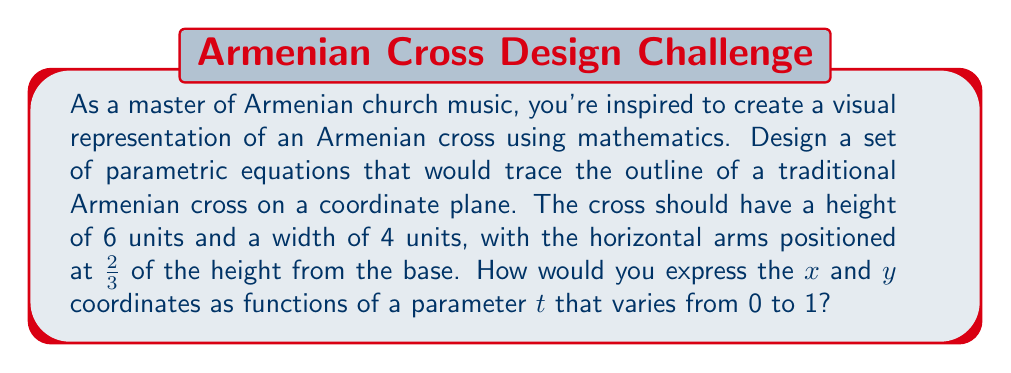Solve this math problem. To create parametric equations for an Armenian cross, we need to break down the shape into segments and define equations for each. Let's approach this step-by-step:

1) First, let's define the dimensions:
   - Height: 6 units
   - Width: 4 units
   - Horizontal arms at y = 4 (2/3 of the height from the base)

2) We'll use piecewise functions for x(t) and y(t), where t varies from 0 to 1.

3) Let's break down the cross into 8 segments, each corresponding to a range of t:
   - 0 ≤ t < 1/8: Bottom to left arm
   - 1/8 ≤ t < 2/8: Left arm
   - 2/8 ≤ t < 3/8: Left arm to top
   - 3/8 ≤ t < 4/8: Top
   - 4/8 ≤ t < 5/8: Top to right arm
   - 5/8 ≤ t < 6/8: Right arm
   - 6/8 ≤ t < 7/8: Right arm to bottom
   - 7/8 ≤ t ≤ 1: Bottom

4) Now, let's define the equations for each segment:

   For x(t):
   $$x(t) = \begin{cases}
   -1 & 0 \leq t < \frac{1}{8} \\
   -2 + 8t & \frac{1}{8} \leq t < \frac{2}{8} \\
   -1 & \frac{2}{8} \leq t < \frac{3}{8} \\
   -2 + 8t & \frac{3}{8} \leq t < \frac{4}{8} \\
   1 & \frac{4}{8} \leq t < \frac{5}{8} \\
   -2 + 8t & \frac{5}{8} \leq t < \frac{6}{8} \\
   1 & \frac{6}{8} \leq t < \frac{7}{8} \\
   6 - 8t & \frac{7}{8} \leq t \leq 1
   \end{cases}$$

   For y(t):
   $$y(t) = \begin{cases}
   8t & 0 \leq t < \frac{1}{8} \\
   1 & \frac{1}{8} \leq t < \frac{2}{8} \\
   -4 + 24t & \frac{2}{8} \leq t < \frac{3}{8} \\
   3 & \frac{3}{8} \leq t < \frac{4}{8} \\
   12 - 24t & \frac{4}{8} \leq t < \frac{5}{8} \\
   1 & \frac{5}{8} \leq t < \frac{6}{8} \\
   8 - 8t & \frac{6}{8} \leq t < \frac{7}{8} \\
   0 & \frac{7}{8} \leq t \leq 1
   \end{cases}$$

5) These equations will trace the outline of an Armenian cross when t varies from 0 to 1.
Answer: The parametric equations for an Armenian cross with height 6 units, width 4 units, and horizontal arms at 2/3 of the height are:

$$x(t) = \begin{cases}
-1 & 0 \leq t < \frac{1}{8} \\
-2 + 8t & \frac{1}{8} \leq t < \frac{2}{8} \\
-1 & \frac{2}{8} \leq t < \frac{3}{8} \\
-2 + 8t & \frac{3}{8} \leq t < \frac{4}{8} \\
1 & \frac{4}{8} \leq t < \frac{5}{8} \\
-2 + 8t & \frac{5}{8} \leq t < \frac{6}{8} \\
1 & \frac{6}{8} \leq t < \frac{7}{8} \\
6 - 8t & \frac{7}{8} \leq t \leq 1
\end{cases}$$

$$y(t) = \begin{cases}
8t & 0 \leq t < \frac{1}{8} \\
1 & \frac{1}{8} \leq t < \frac{2}{8} \\
-4 + 24t & \frac{2}{8} \leq t < \frac{3}{8} \\
3 & \frac{3}{8} \leq t < \frac{4}{8} \\
12 - 24t & \frac{4}{8} \leq t < \frac{5}{8} \\
1 & \frac{5}{8} \leq t < \frac{6}{8} \\
8 - 8t & \frac{6}{8} \leq t < \frac{7}{8} \\
0 & \frac{7}{8} \leq t \leq 1
\end{cases}$$

where $0 \leq t \leq 1$ 